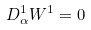<formula> <loc_0><loc_0><loc_500><loc_500>D _ { \alpha } ^ { 1 } W ^ { 1 } = 0</formula> 